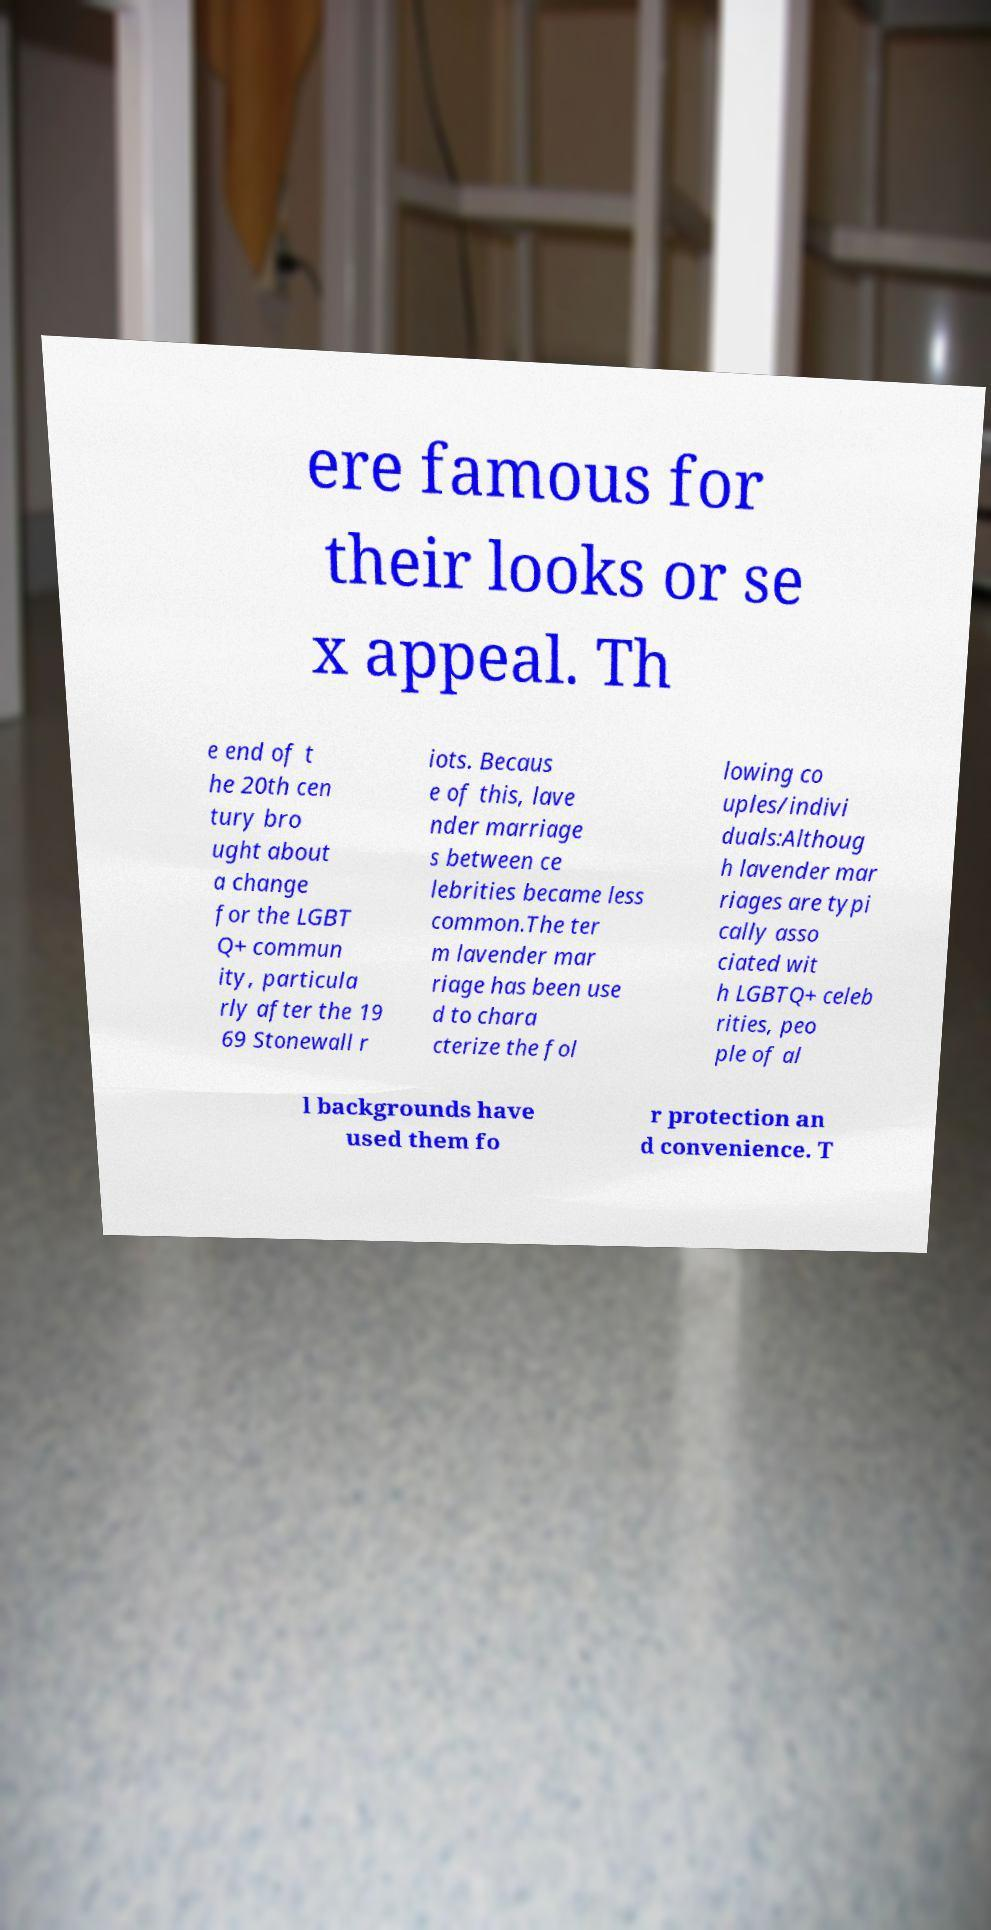Can you accurately transcribe the text from the provided image for me? ere famous for their looks or se x appeal. Th e end of t he 20th cen tury bro ught about a change for the LGBT Q+ commun ity, particula rly after the 19 69 Stonewall r iots. Becaus e of this, lave nder marriage s between ce lebrities became less common.The ter m lavender mar riage has been use d to chara cterize the fol lowing co uples/indivi duals:Althoug h lavender mar riages are typi cally asso ciated wit h LGBTQ+ celeb rities, peo ple of al l backgrounds have used them fo r protection an d convenience. T 